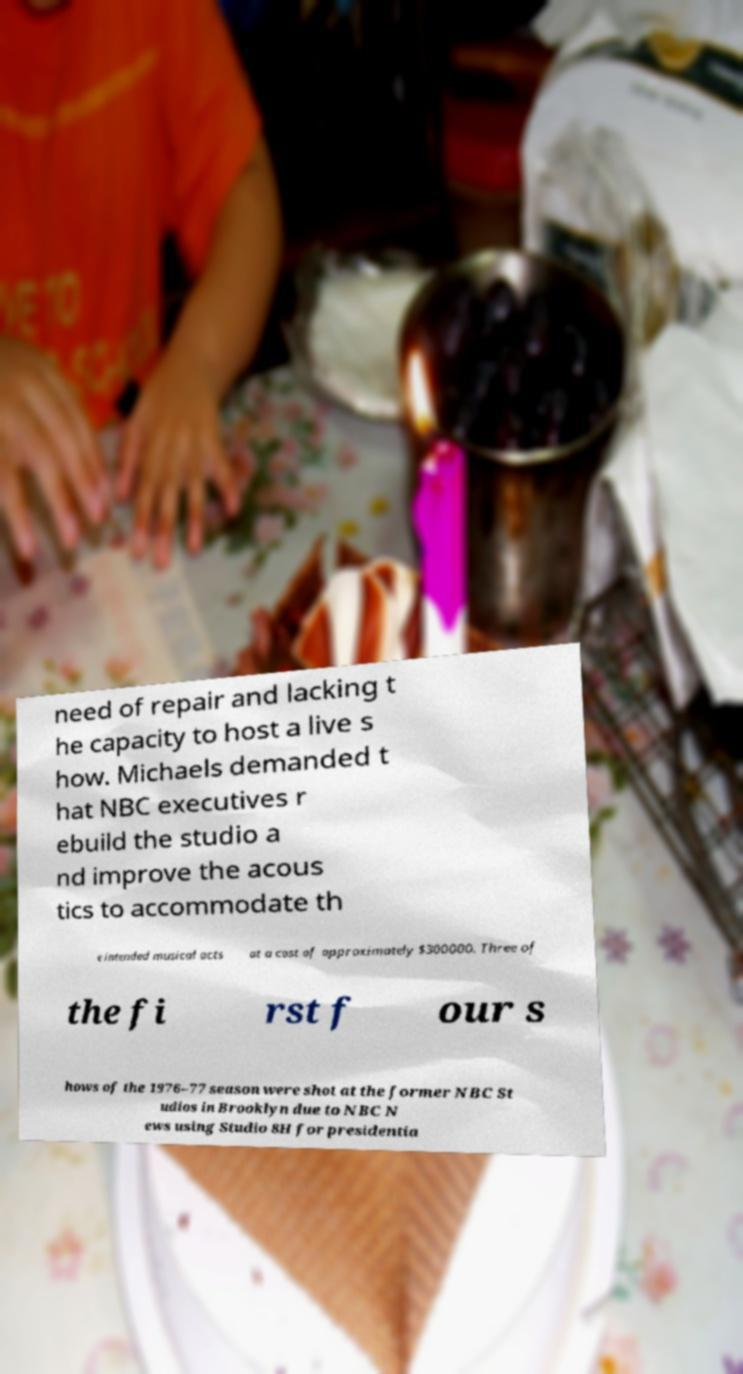Please identify and transcribe the text found in this image. need of repair and lacking t he capacity to host a live s how. Michaels demanded t hat NBC executives r ebuild the studio a nd improve the acous tics to accommodate th e intended musical acts at a cost of approximately $300000. Three of the fi rst f our s hows of the 1976–77 season were shot at the former NBC St udios in Brooklyn due to NBC N ews using Studio 8H for presidentia 